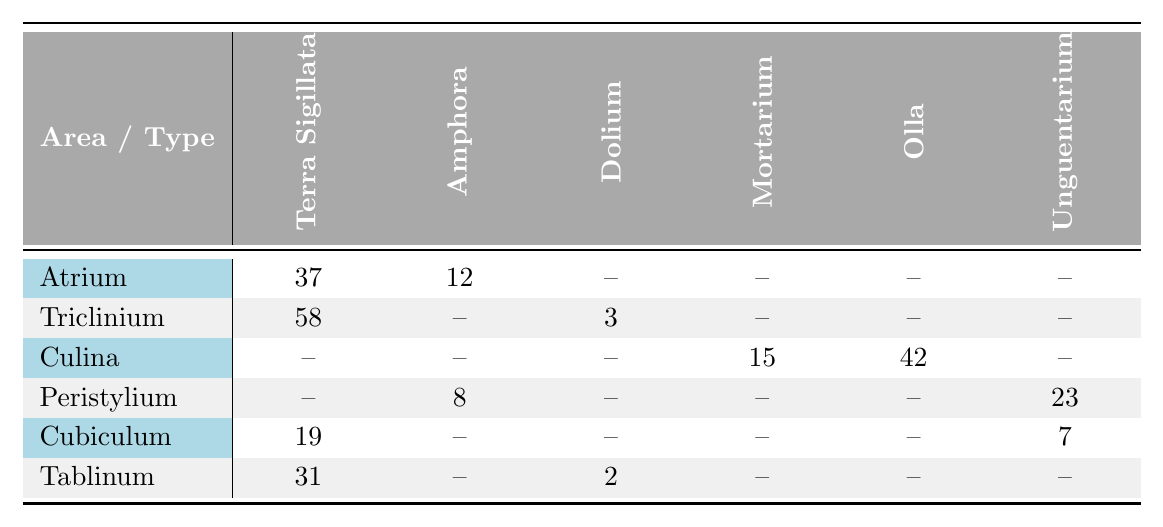What is the total count of Terra Sigillata sherds recovered from the excavation? From the table, we can see the counts for Terra Sigillata in different areas: Atrium (37), Triclinium (58), Cubiculum (19), and Tablinum (31). Adding these values together: 37 + 58 + 19 + 31 = 145.
Answer: 145 Which area has the highest number of Amphora sherds? The only areas where Amphora sherds are found are Atrium (12), Triclinium (none), Peristylium (8), and Tablinum (none). Out of these, Atrium has the highest count of 12.
Answer: Atrium What type of pottery sherd is found in the greatest abundance in the Triclinium? In the Triclinium, the types of pottery sherds listed are Terra Sigillata (58) and Dolium (3). The Terra Sigillata has the highest count of 58, which is greater than the Dolium.
Answer: Terra Sigillata Is there any area where Dolium is not present? Checking the table, Dolium is found in Triclinium (3) and Tablinum (2). The areas where Dolium is not present are Atrium, Culina, Peristylium, and Cubiculum. Therefore, yes, there are areas without Dolium.
Answer: Yes What is the average count of Olla sherds across all relevant areas? Olla sherds are found in Culina (42). Since it is the only instance in the table, the average is simply 42/1 = 42.
Answer: 42 How many more Unguentarium sherds are in Peristylium compared to Cubiculum? Peristylium has 23 Unguentarium sherds, while Cubiculum has 7. The difference in counts is 23 - 7 = 16.
Answer: 16 What is the total number of pottery sherds across all excavation areas? Adding the counts from all entries: 37 (Atrium Terra Sigillata) + 12 (Atrium Amphora) + 58 (Triclinium Terra Sigillata) + 3 (Triclinium Dolium) + 42 (Culina Olla) + 15 (Culina Mortarium) + 23 (Peristylium Unguentarium) + 8 (Peristylium Amphora) + 19 (Cubiculum Terra Sigillata) + 7 (Cubiculum Unguentarium) + 31 (Tablinum Terra Sigillata) + 2 (Tablinum Dolium) =  315.
Answer: 315 Which area has the least diversity in pottery type? The Culina has only two different types of pottery: Olla and Mortarium, while the others have three or more types. Therefore, Culina shows the least diversity.
Answer: Culina How many total counts of pottery sherds are found in the Peristylium area? In Peristylium, we have 8 (Amphora) + 23 (Unguentarium) = 31.
Answer: 31 Is there a pottery type that is uniquely found in a single area? Yes, the Dolium is only found in Triclinium and Tablinum. Therefore, it is not unique to a single area. No other pottery types are uniquely confined to a single area.
Answer: No 